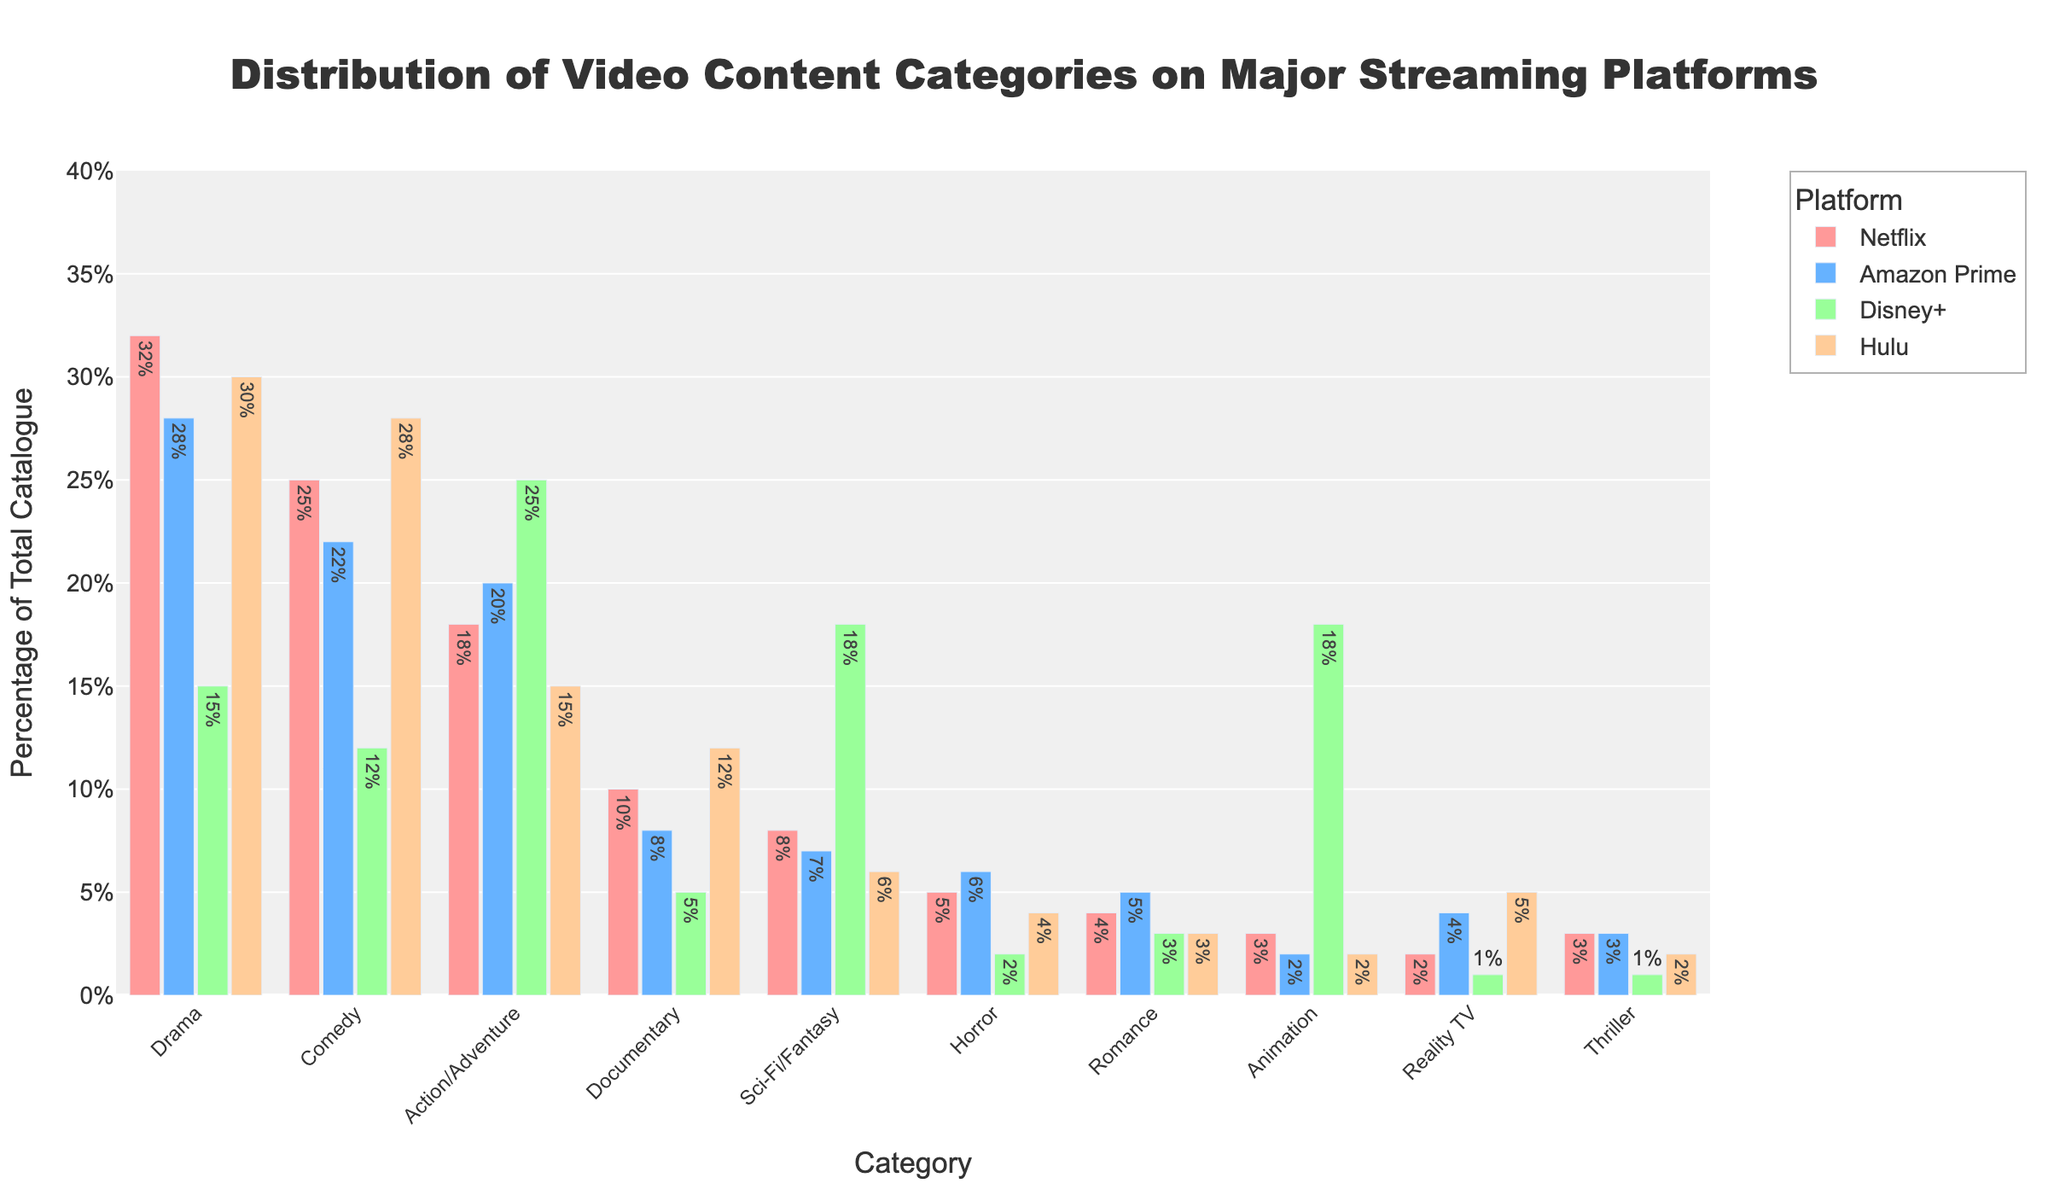What is the most common video content category on Netflix? By examining the height of the bars representing Netflix, we find that the Drama category has the tallest bar, signifying the highest percentage.
Answer: Drama Which platform has the highest percentage of Action/Adventure content? Compare the heights of the bars for Action/Adventure across all four platforms. Disney+ has the tallest bar in this category.
Answer: Disney+ How does the percentage of Comedy content on Hulu compare to Amazon Prime? By looking at the bars for Comedy on both Hulu and Amazon Prime, we see that the Hulu bar is taller, indicating a higher percentage. Hulu's Comedy content is at 28%, while Amazon Prime's is at 22%.
Answer: Hulu has a higher percentage What is the difference in the percentage of Documentary content between Disney+ and Hulu? Disney+ has 5% Documentary content, and Hulu has 12%. The difference is 12% - 5% = 7%.
Answer: 7% On which platform does Animation content represent the highest percentage of the total catalog? The tallest bar for Animation content is on Disney+, indicating it has the highest percentage.
Answer: Disney+ What is the least common video content category on Disney+? Looking at the bars for Disney+, the Horror category has the shortest bar, signifying the lowest percentage.
Answer: Horror Which platform has a higher percentage of Horror content, Netflix or Hulu? Comparing the bars for Horror content on both platforms, we see that Netflix has 5% and Hulu has 4%.
Answer: Netflix Which three platforms have a higher percentage of Drama content than Sci-Fi/Fantasy content? For each of Netflix (32% Drama vs. 8% Sci-Fi/Fantasy), Amazon Prime (28% Drama vs. 7% Sci-Fi/Fantasy), and Hulu (30% Drama vs. 6% Sci-Fi/Fantasy), Drama has a higher percentage than Sci-Fi/Fantasy. Disney+ is not included because its Sci-Fi/Fantasy percentage (18%) is higher.
Answer: Netflix, Amazon Prime, Hulu What is the combined percentage of Romance content across all platforms? Add the percentage values for Romance content across all four platforms: 4% (Netflix) + 5% (Amazon Prime) + 3% (Disney+) + 3% (Hulu) = 15%.
Answer: 15% How does the percentage of Reality TV content on Hulu compare to the other platforms? The bar for Reality TV content on Hulu shows 5%, while Netflix, Amazon Prime, and Disney+ show 2%, 4%, and 1%, respectively. Thus, Hulu has the highest percentage of Reality TV content.
Answer: Highest 